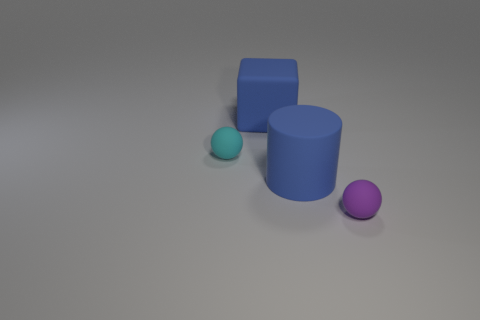What number of objects are large matte objects that are right of the large blue rubber cube or tiny rubber balls that are on the left side of the purple sphere?
Your response must be concise. 2. Are there an equal number of purple spheres behind the purple object and small cyan balls that are behind the tiny cyan matte object?
Ensure brevity in your answer.  Yes. Are there more purple objects that are on the left side of the blue cylinder than small blue rubber cylinders?
Make the answer very short. No. How many objects are either blue objects that are in front of the small cyan thing or big blue cylinders?
Provide a succinct answer. 1. How many other things have the same material as the tiny cyan object?
Keep it short and to the point. 3. There is a thing that is the same color as the big cube; what shape is it?
Your response must be concise. Cylinder. Is there a purple object of the same shape as the small cyan matte object?
Keep it short and to the point. Yes. What is the shape of the purple rubber thing that is the same size as the cyan matte thing?
Make the answer very short. Sphere. There is a large cylinder; is it the same color as the large rubber object behind the cylinder?
Keep it short and to the point. Yes. There is a blue matte thing in front of the big block; how many tiny spheres are on the left side of it?
Your answer should be very brief. 1. 